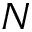Convert formula to latex. <formula><loc_0><loc_0><loc_500><loc_500>N</formula> 